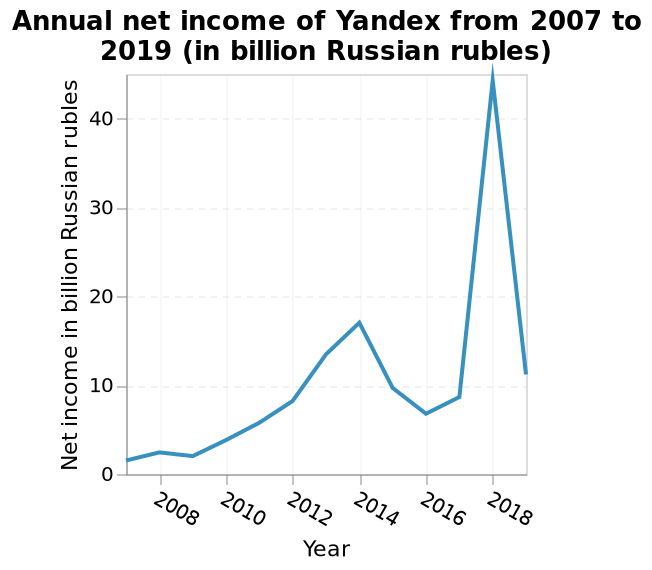<image>
What was the trend in ruble amounts from 2007 to 2018?  The trend in ruble amounts was a steady climb from 2 billion in 2007 to a peak of over 45 billion in 2018. 